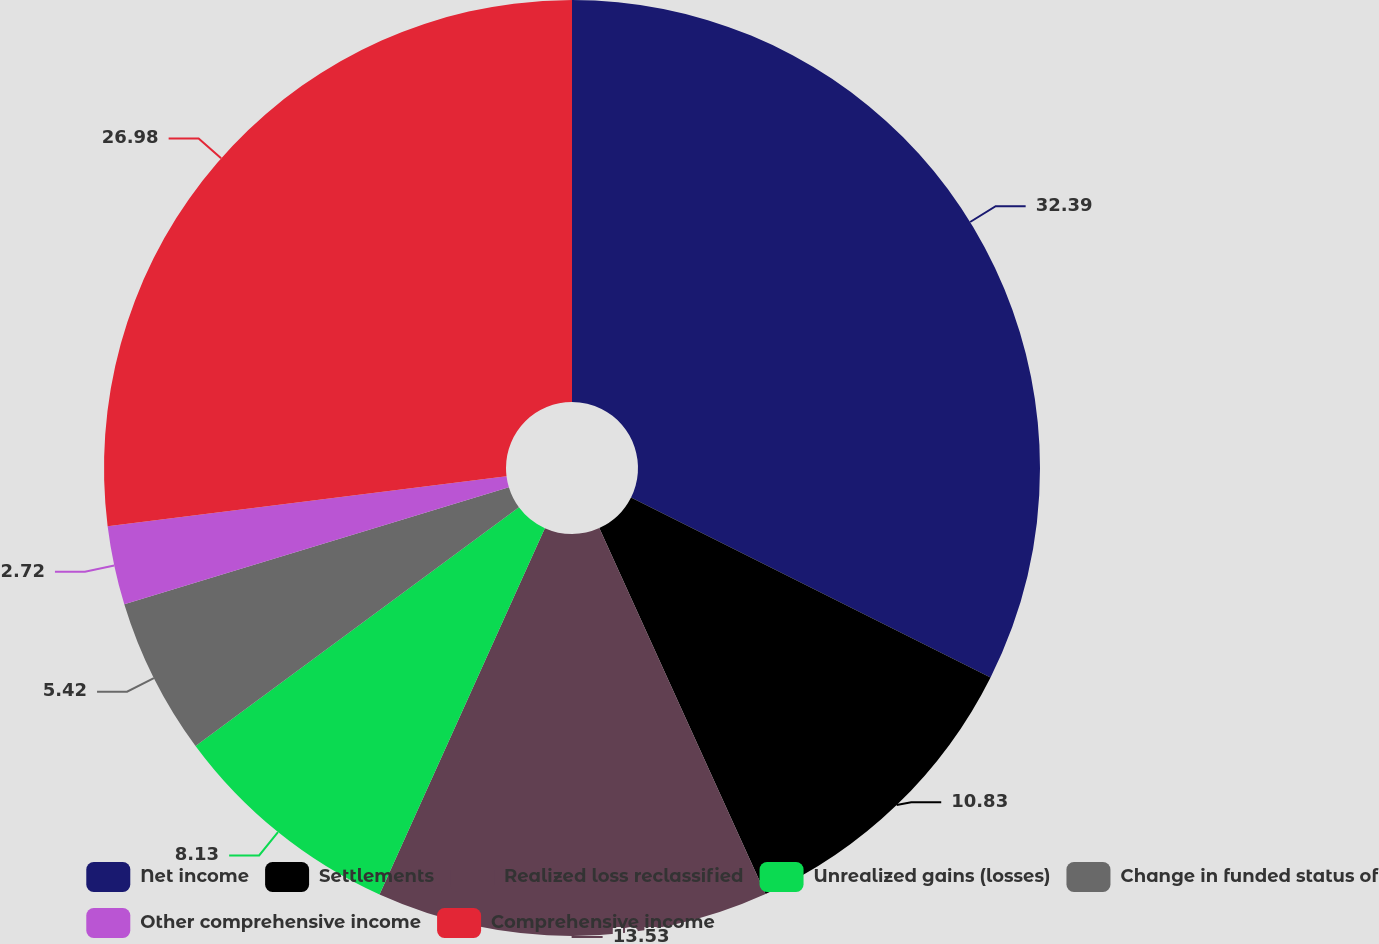<chart> <loc_0><loc_0><loc_500><loc_500><pie_chart><fcel>Net income<fcel>Settlements<fcel>Realized loss reclassified<fcel>Unrealized gains (losses)<fcel>Change in funded status of<fcel>Other comprehensive income<fcel>Comprehensive income<nl><fcel>32.38%<fcel>10.83%<fcel>13.53%<fcel>8.13%<fcel>5.42%<fcel>2.72%<fcel>26.98%<nl></chart> 